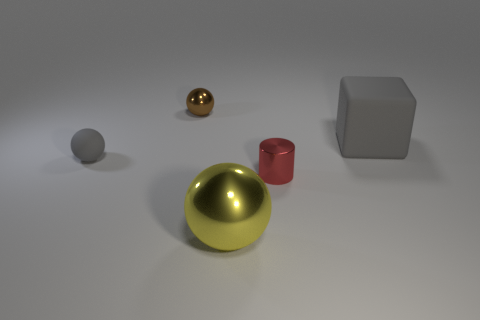Is the small ball in front of the brown metal object made of the same material as the red object?
Give a very brief answer. No. What number of red blocks are there?
Your answer should be very brief. 0. What number of objects are metallic cylinders or big yellow spheres?
Keep it short and to the point. 2. There is a yellow sphere that is in front of the gray matte block behind the cylinder; what number of metallic objects are behind it?
Make the answer very short. 2. Are there any other things that are the same color as the tiny rubber thing?
Your response must be concise. Yes. There is a big thing that is left of the large gray cube; does it have the same color as the metallic object that is right of the big yellow metal object?
Your answer should be compact. No. Is the number of big rubber things on the right side of the tiny gray matte sphere greater than the number of matte blocks left of the yellow shiny thing?
Ensure brevity in your answer.  Yes. What is the big gray thing made of?
Provide a succinct answer. Rubber. There is a tiny object that is behind the gray matte object on the right side of the gray object that is to the left of the small brown object; what is its shape?
Ensure brevity in your answer.  Sphere. How many other objects are the same material as the big gray object?
Your response must be concise. 1. 